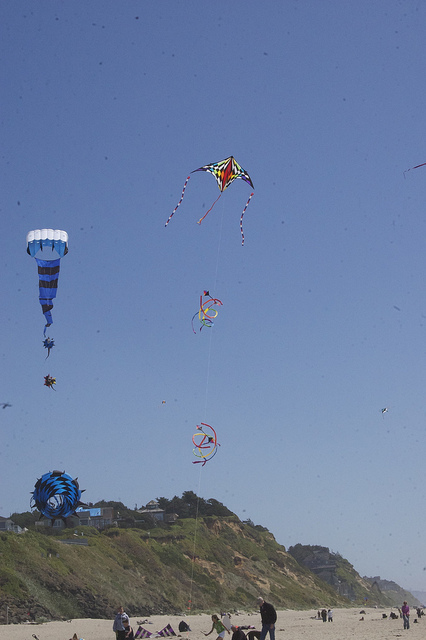<image>Where is the blue umbrella? The blue umbrella is not visible in the image. However, it could potentially be on a beach, ski hill, or even in the sky. Where is the blue umbrella? I am not sure where the blue umbrella is. It can be seen on the beach or on the hill. 